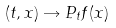<formula> <loc_0><loc_0><loc_500><loc_500>( t , x ) \rightarrow P _ { t } f ( x )</formula> 